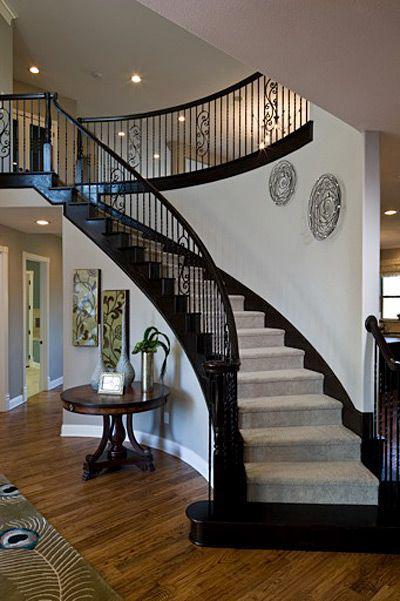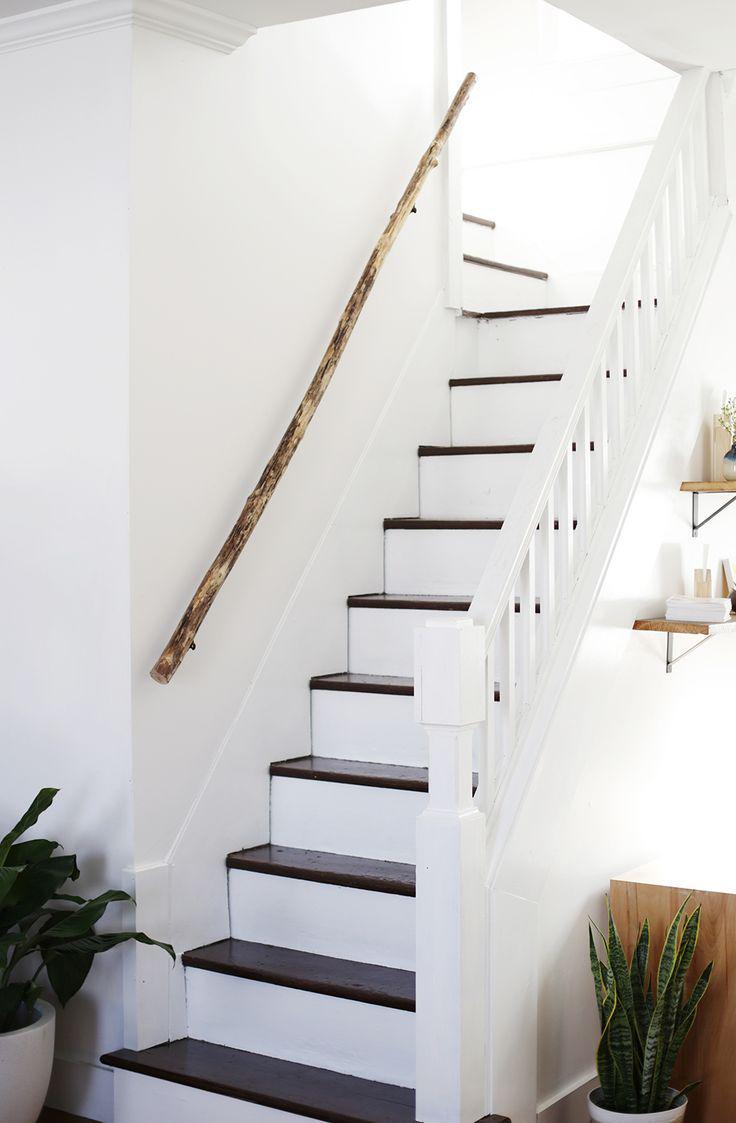The first image is the image on the left, the second image is the image on the right. For the images displayed, is the sentence "One image shows a diagonal 'floating' staircase in front of a brick-like wall and over an open stairwell." factually correct? Answer yes or no. No. The first image is the image on the left, the second image is the image on the right. Examine the images to the left and right. Is the description "The right image contains a staircase with a black handrail." accurate? Answer yes or no. No. 